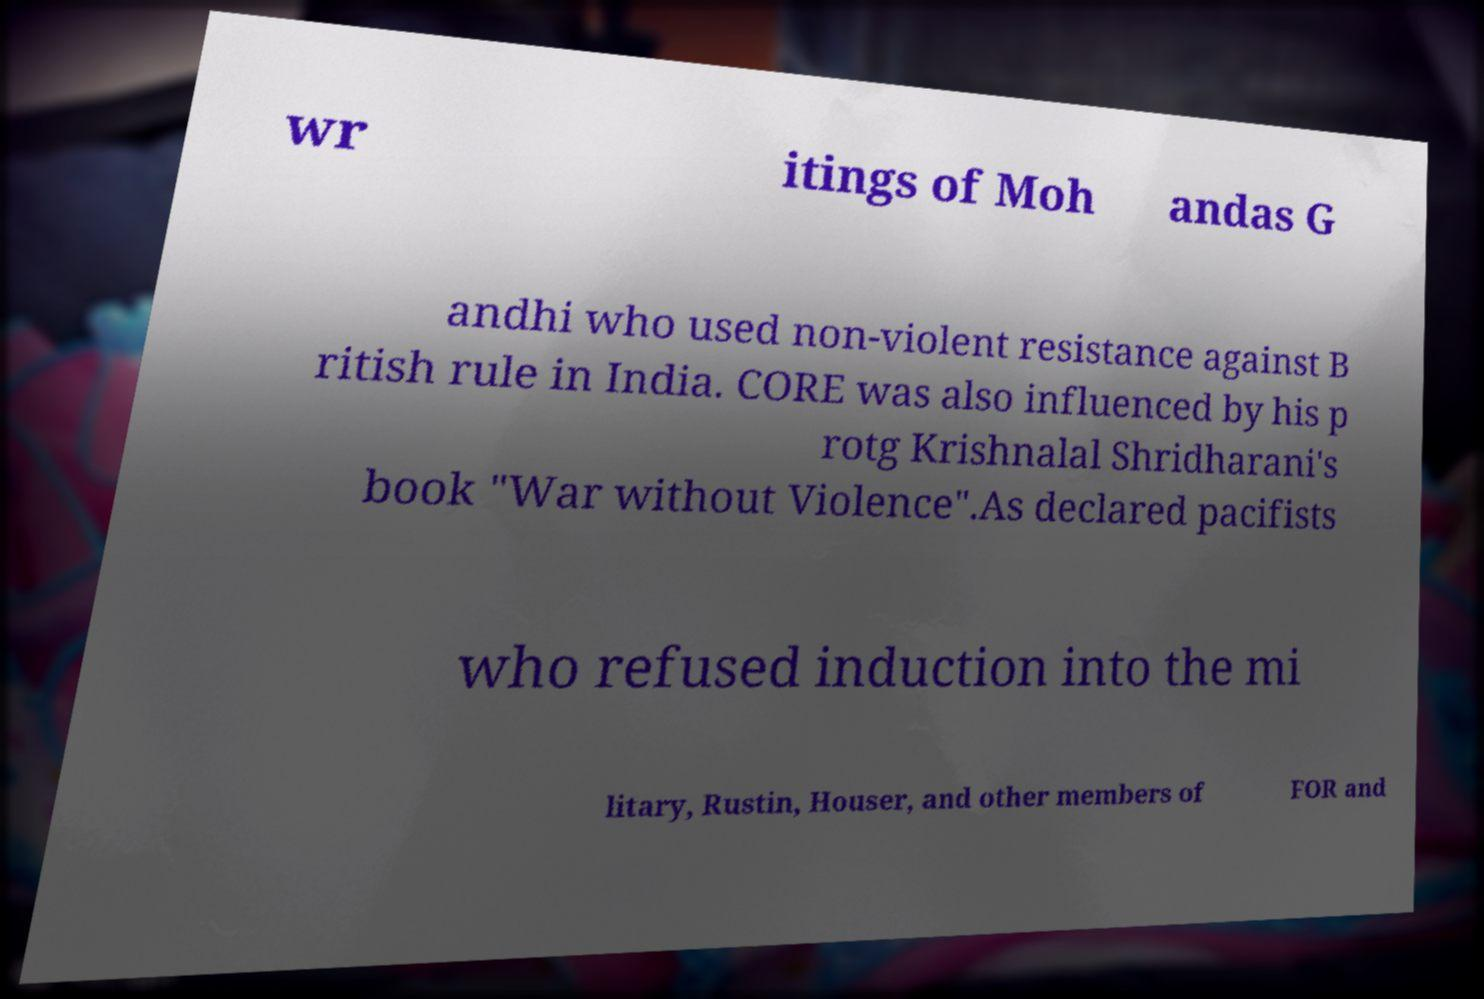Can you read and provide the text displayed in the image?This photo seems to have some interesting text. Can you extract and type it out for me? wr itings of Moh andas G andhi who used non-violent resistance against B ritish rule in India. CORE was also influenced by his p rotg Krishnalal Shridharani's book "War without Violence".As declared pacifists who refused induction into the mi litary, Rustin, Houser, and other members of FOR and 